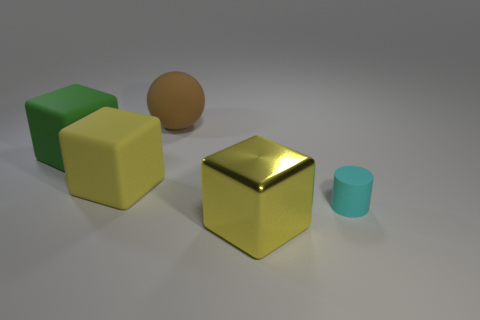Add 2 yellow metal things. How many objects exist? 7 Subtract all cylinders. How many objects are left? 4 Add 3 small matte objects. How many small matte objects are left? 4 Add 5 brown things. How many brown things exist? 6 Subtract 0 blue blocks. How many objects are left? 5 Subtract all rubber blocks. Subtract all big brown balls. How many objects are left? 2 